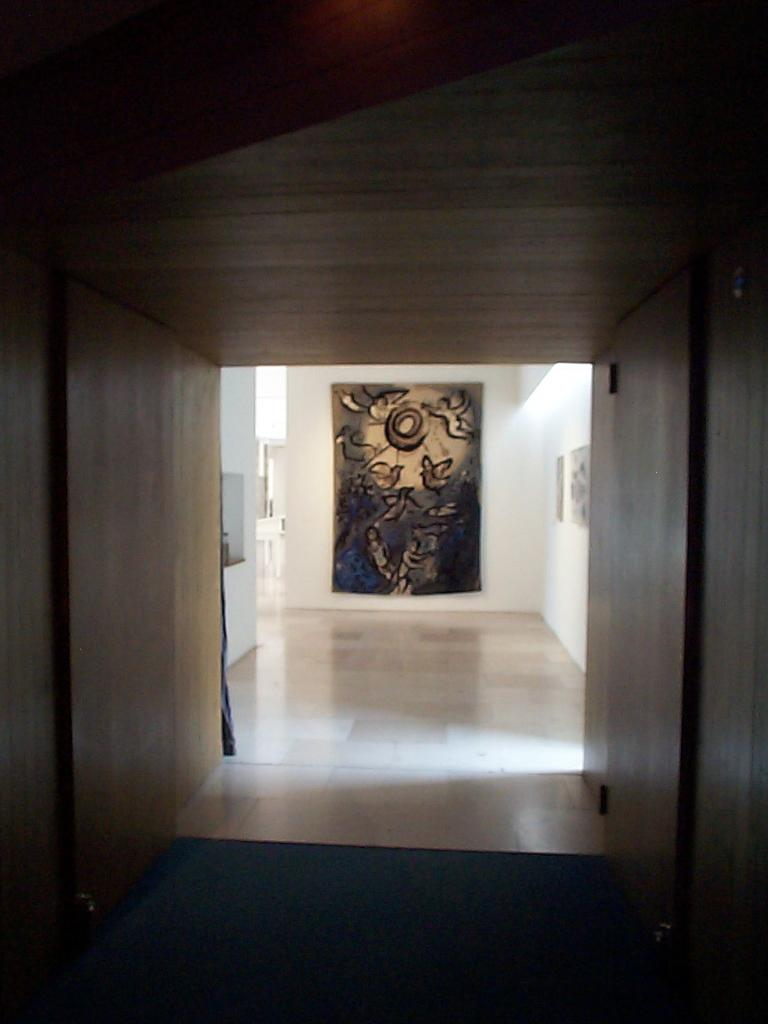What type of material is used for the roof in the image? The roof in the image is made of wood. What type of material is used for the walls in the image? The walls in the image are also made of wood. What color are the walls behind the wooden walls? The walls behind the wooden walls are white. What can be seen in the image that might be used for support or decoration? There is a frame present in the image. Where is the hose located in the image? There is no hose present in the image. What type of bed can be seen in the image? There is no bed present in the image. 